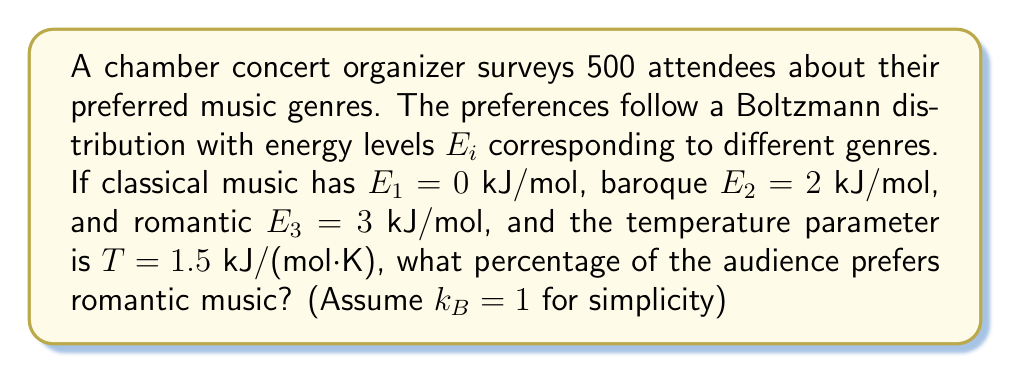Could you help me with this problem? To solve this problem, we'll use the Boltzmann distribution formula and follow these steps:

1) The Boltzmann distribution is given by:

   $$P_i = \frac{e^{-E_i/kT}}{\sum_j e^{-E_j/kT}}$$

2) We need to calculate the denominator (partition function) first:

   $$Z = e^{-E_1/kT} + e^{-E_2/kT} + e^{-E_3/kT}$$

3) Substituting the values ($k_B = 1$, $T = 1.5$):

   $$Z = e^{-0/1.5} + e^{-2/1.5} + e^{-3/1.5} = 1 + e^{-4/3} + e^{-2}$$

4) Calculate Z:

   $$Z = 1 + 0.2636 + 0.1353 = 1.3989$$

5) Now calculate the probability for romantic music ($E_3 = 3$):

   $$P_3 = \frac{e^{-3/1.5}}{1.3989} = \frac{0.1353}{1.3989} = 0.0967$$

6) Convert to percentage:

   $$0.0967 \times 100\% = 9.67\%$$
Answer: 9.67% 